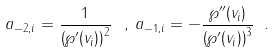<formula> <loc_0><loc_0><loc_500><loc_500>a _ { - 2 , i } = \frac { 1 } { \left ( \wp ^ { \prime } ( v _ { i } ) \right ) ^ { 2 } } \, \ , \, a _ { - 1 , i } = - \frac { \wp ^ { \prime \prime } ( v _ { i } ) } { \left ( \wp ^ { \prime } ( v _ { i } ) \right ) ^ { 3 } } \ .</formula> 